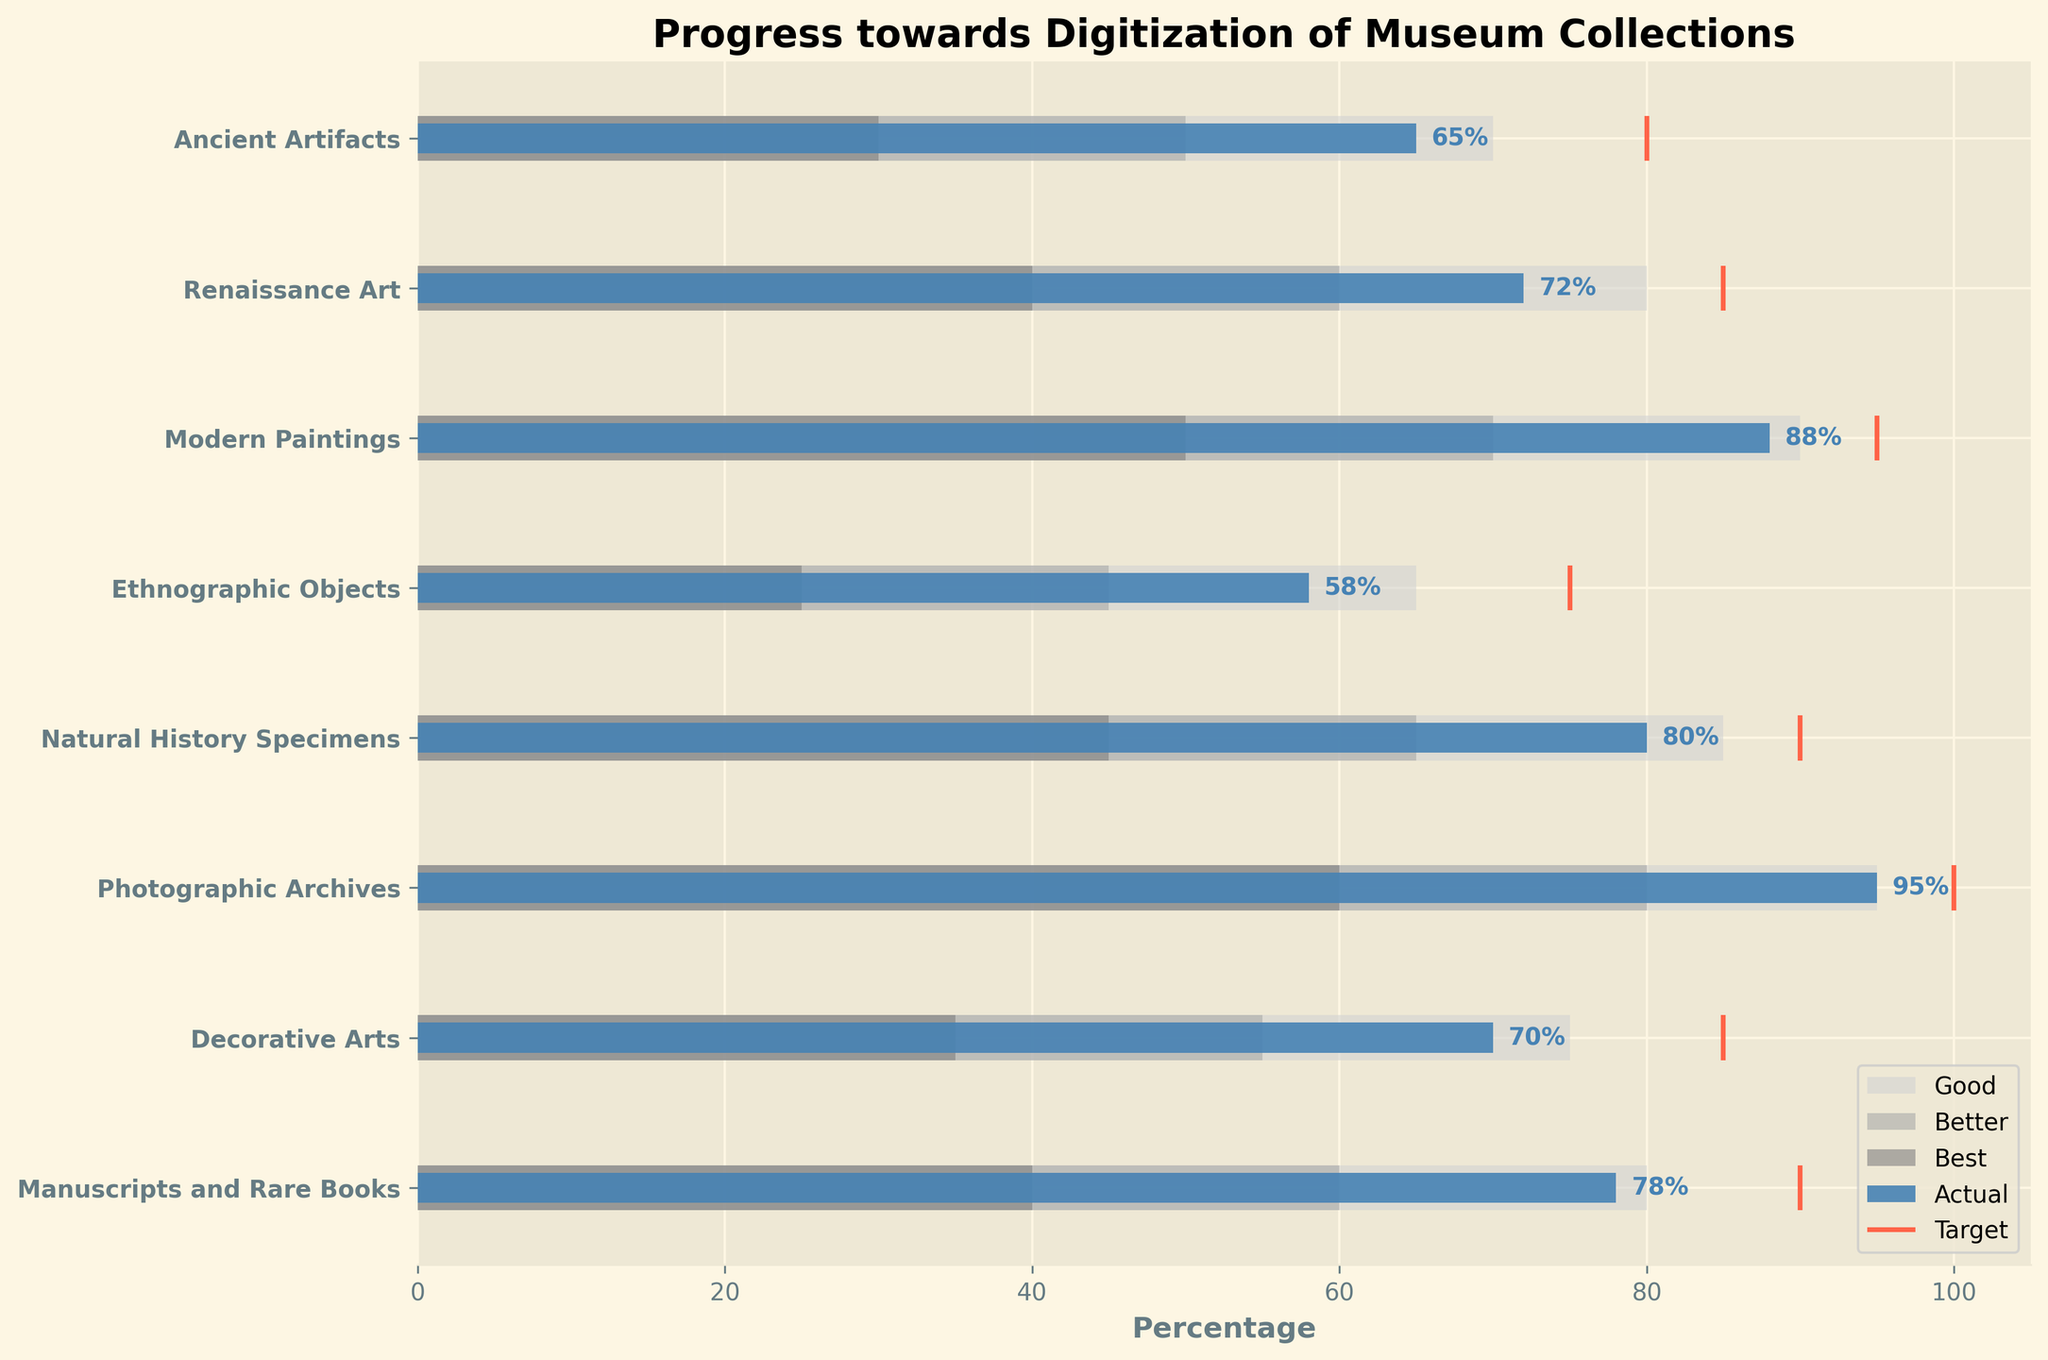What is the title of the chart? The title is located at the top of the chart and is written prominently.
Answer: Progress towards Digitization of Museum Collections How many categories are displayed in the chart? Count the number of different categories listed on the y-axis.
Answer: 8 Which category has the highest actual progress? Identify the bar that reaches the farthest to the right.
Answer: Photographic Archives Is there any category where the actual progress meets or exceeds the target? Check if the actual progress bar reaches or surpasses the target line.
Answer: No Which category has the lowest actual progress? Identify the bar that extends the shortest distance to the right.
Answer: Ethnographic Objects What is the target progress for Natural History Specimens? Look at the location of the target line (vertical line) corresponding to Natural History Specimens on the y-axis.
Answer: 90% How much more progress is needed for Ancient Artifacts to reach its target? Subtract the actual percentage of Ancient Artifacts from its target percentage: 80 - 65.
Answer: 15% Which categories' actual progress falls within the "Better" range? Check the length of the actual progress bars and see if they fall within the second range (medium gray): Renaissance Art (40-60), Modern Paintings (70-90), Decorative Arts (55-75), Manuscripts and Rare Books (60-80).
Answer: Renaissance Art, Modern Paintings, Decorative Arts, Manuscripts and Rare Books Between Renaissance Art and Modern Paintings, which category's actual progress is closer to its target? Calculate the difference between the actual progress and the target for each category: Renaissance Art (85 - 72 = 13), Modern Paintings (95 - 88 = 7).
Answer: Modern Paintings 